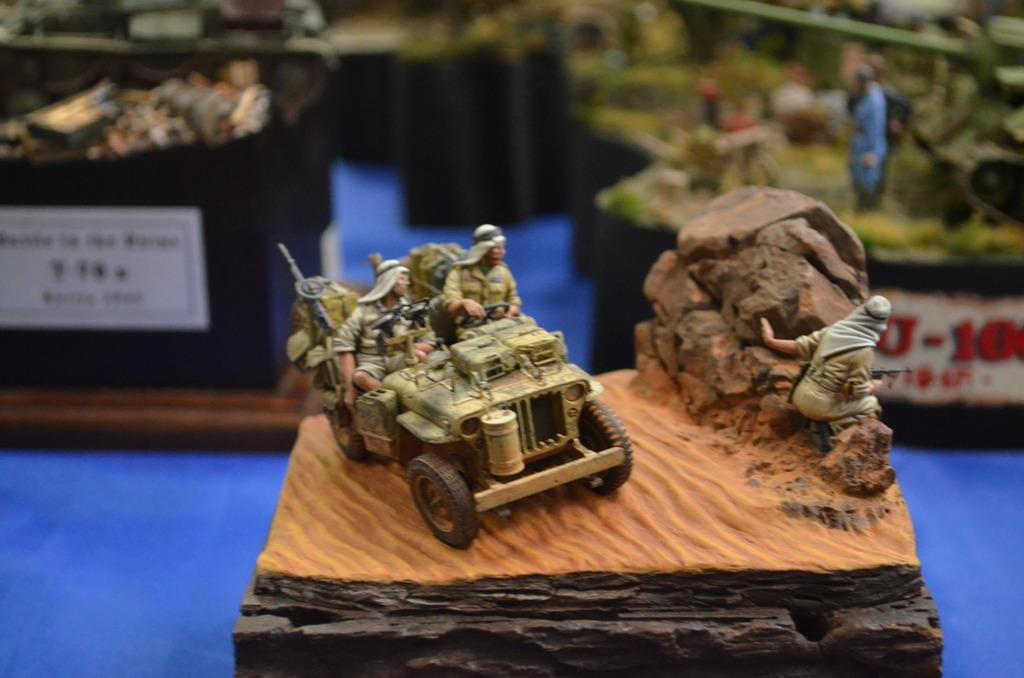What types of objects can be seen in the image? There are toys and stickers in the image. Can you describe the background of the image? The background of the image is blurred. What type of ornament is hanging from the ceiling in the image? There is no ornament hanging from the ceiling in the image; it only features toys and stickers. What is the air quality like in the image? The provided facts do not give any information about the air quality in the image. 